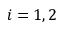<formula> <loc_0><loc_0><loc_500><loc_500>i = 1 , 2</formula> 